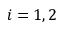<formula> <loc_0><loc_0><loc_500><loc_500>i = 1 , 2</formula> 